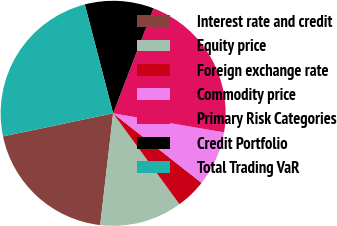Convert chart. <chart><loc_0><loc_0><loc_500><loc_500><pie_chart><fcel>Interest rate and credit<fcel>Equity price<fcel>Foreign exchange rate<fcel>Commodity price<fcel>Primary Risk Categories<fcel>Credit Portfolio<fcel>Total Trading VaR<nl><fcel>19.88%<fcel>11.87%<fcel>4.36%<fcel>7.9%<fcel>21.87%<fcel>9.89%<fcel>24.24%<nl></chart> 